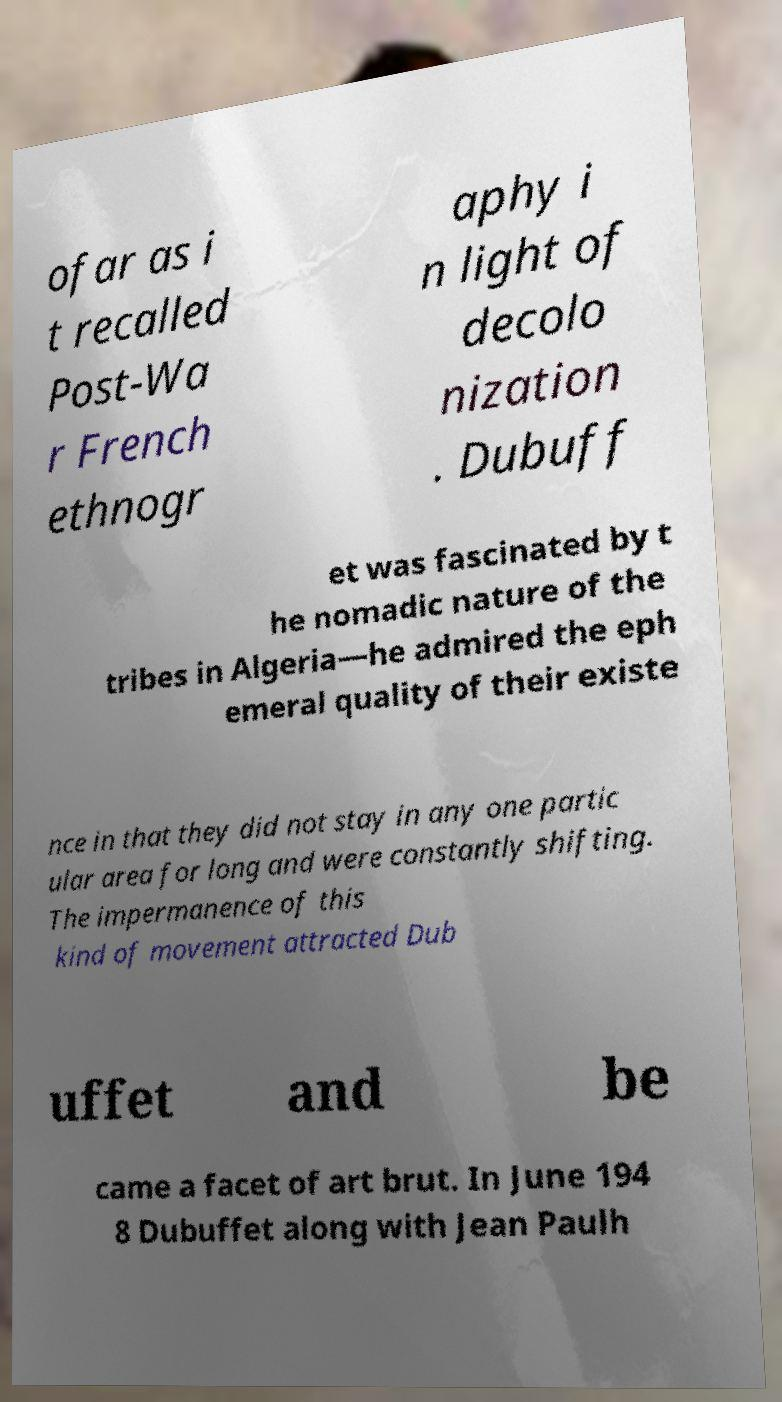For documentation purposes, I need the text within this image transcribed. Could you provide that? ofar as i t recalled Post-Wa r French ethnogr aphy i n light of decolo nization . Dubuff et was fascinated by t he nomadic nature of the tribes in Algeria—he admired the eph emeral quality of their existe nce in that they did not stay in any one partic ular area for long and were constantly shifting. The impermanence of this kind of movement attracted Dub uffet and be came a facet of art brut. In June 194 8 Dubuffet along with Jean Paulh 